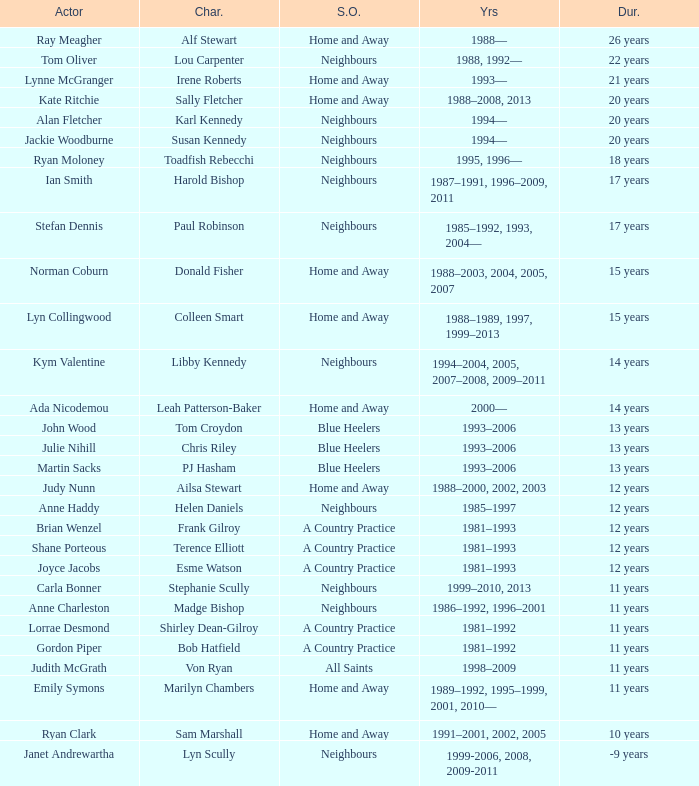Which actor played Harold Bishop for 17 years? Ian Smith. 